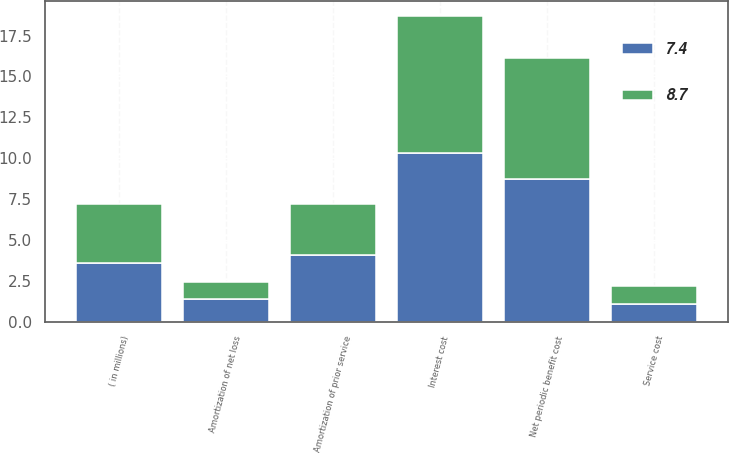<chart> <loc_0><loc_0><loc_500><loc_500><stacked_bar_chart><ecel><fcel>( in millions)<fcel>Service cost<fcel>Interest cost<fcel>Amortization of net loss<fcel>Amortization of prior service<fcel>Net periodic benefit cost<nl><fcel>8.7<fcel>3.6<fcel>1.1<fcel>8.4<fcel>1<fcel>3.1<fcel>7.4<nl><fcel>7.4<fcel>3.6<fcel>1.1<fcel>10.3<fcel>1.4<fcel>4.1<fcel>8.7<nl></chart> 